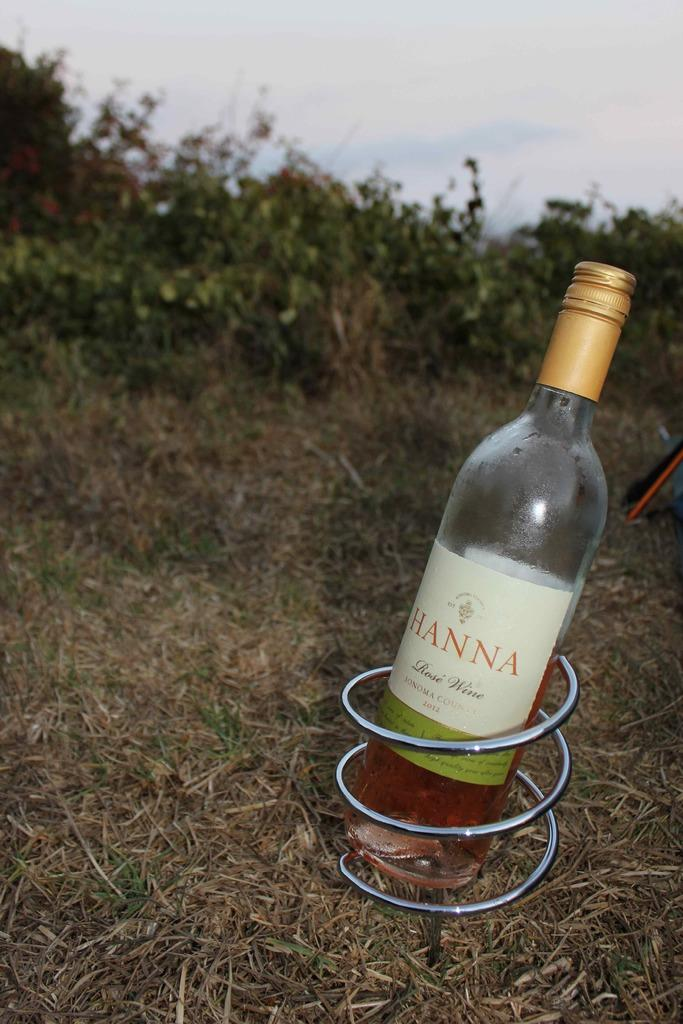<image>
Relay a brief, clear account of the picture shown. A bottle of wine that says Hanna is in a metal coil on a grass hill. 